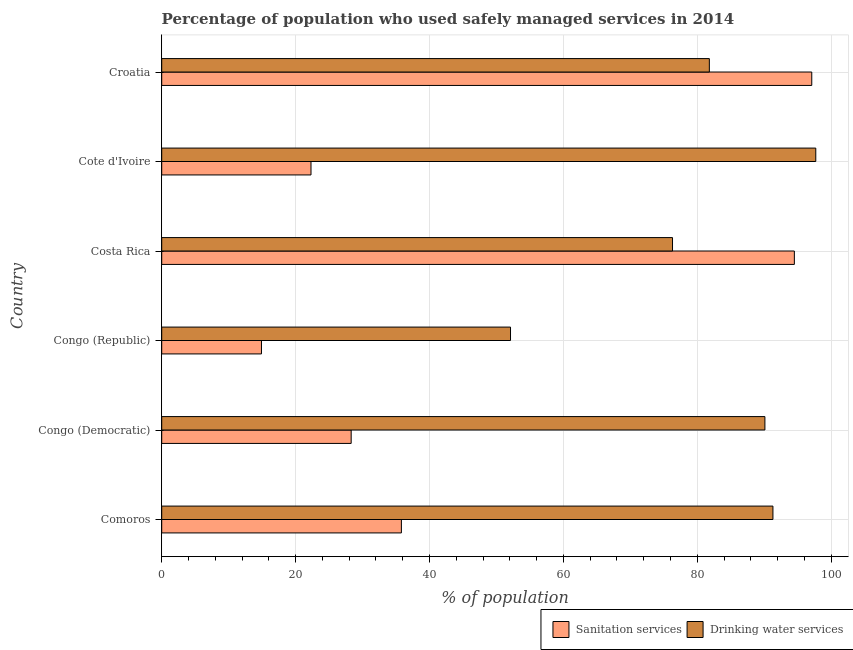How many different coloured bars are there?
Make the answer very short. 2. How many groups of bars are there?
Make the answer very short. 6. How many bars are there on the 3rd tick from the bottom?
Make the answer very short. 2. What is the label of the 5th group of bars from the top?
Ensure brevity in your answer.  Congo (Democratic). What is the percentage of population who used drinking water services in Comoros?
Provide a short and direct response. 91.3. Across all countries, what is the maximum percentage of population who used drinking water services?
Ensure brevity in your answer.  97.7. Across all countries, what is the minimum percentage of population who used sanitation services?
Make the answer very short. 14.9. In which country was the percentage of population who used sanitation services maximum?
Offer a terse response. Croatia. In which country was the percentage of population who used sanitation services minimum?
Provide a short and direct response. Congo (Republic). What is the total percentage of population who used sanitation services in the graph?
Keep it short and to the point. 292.9. What is the difference between the percentage of population who used sanitation services in Congo (Democratic) and the percentage of population who used drinking water services in Comoros?
Make the answer very short. -63. What is the average percentage of population who used sanitation services per country?
Give a very brief answer. 48.82. What is the difference between the percentage of population who used drinking water services and percentage of population who used sanitation services in Comoros?
Your answer should be very brief. 55.5. In how many countries, is the percentage of population who used sanitation services greater than 92 %?
Ensure brevity in your answer.  2. What is the ratio of the percentage of population who used drinking water services in Costa Rica to that in Cote d'Ivoire?
Give a very brief answer. 0.78. What is the difference between the highest and the lowest percentage of population who used sanitation services?
Keep it short and to the point. 82.2. In how many countries, is the percentage of population who used sanitation services greater than the average percentage of population who used sanitation services taken over all countries?
Offer a terse response. 2. What does the 1st bar from the top in Cote d'Ivoire represents?
Your response must be concise. Drinking water services. What does the 1st bar from the bottom in Costa Rica represents?
Provide a short and direct response. Sanitation services. How many bars are there?
Offer a very short reply. 12. What is the difference between two consecutive major ticks on the X-axis?
Your response must be concise. 20. Does the graph contain any zero values?
Offer a terse response. No. Where does the legend appear in the graph?
Make the answer very short. Bottom right. How are the legend labels stacked?
Ensure brevity in your answer.  Horizontal. What is the title of the graph?
Give a very brief answer. Percentage of population who used safely managed services in 2014. Does "Technicians" appear as one of the legend labels in the graph?
Provide a succinct answer. No. What is the label or title of the X-axis?
Your response must be concise. % of population. What is the % of population in Sanitation services in Comoros?
Your answer should be very brief. 35.8. What is the % of population of Drinking water services in Comoros?
Your answer should be very brief. 91.3. What is the % of population in Sanitation services in Congo (Democratic)?
Your answer should be compact. 28.3. What is the % of population of Drinking water services in Congo (Democratic)?
Provide a short and direct response. 90.1. What is the % of population of Drinking water services in Congo (Republic)?
Offer a very short reply. 52.1. What is the % of population in Sanitation services in Costa Rica?
Your answer should be very brief. 94.5. What is the % of population of Drinking water services in Costa Rica?
Give a very brief answer. 76.3. What is the % of population in Sanitation services in Cote d'Ivoire?
Ensure brevity in your answer.  22.3. What is the % of population of Drinking water services in Cote d'Ivoire?
Provide a succinct answer. 97.7. What is the % of population of Sanitation services in Croatia?
Provide a succinct answer. 97.1. What is the % of population of Drinking water services in Croatia?
Your answer should be very brief. 81.8. Across all countries, what is the maximum % of population of Sanitation services?
Ensure brevity in your answer.  97.1. Across all countries, what is the maximum % of population in Drinking water services?
Your answer should be compact. 97.7. Across all countries, what is the minimum % of population in Drinking water services?
Make the answer very short. 52.1. What is the total % of population in Sanitation services in the graph?
Your answer should be compact. 292.9. What is the total % of population of Drinking water services in the graph?
Offer a terse response. 489.3. What is the difference between the % of population of Sanitation services in Comoros and that in Congo (Democratic)?
Provide a short and direct response. 7.5. What is the difference between the % of population of Sanitation services in Comoros and that in Congo (Republic)?
Provide a succinct answer. 20.9. What is the difference between the % of population of Drinking water services in Comoros and that in Congo (Republic)?
Ensure brevity in your answer.  39.2. What is the difference between the % of population of Sanitation services in Comoros and that in Costa Rica?
Give a very brief answer. -58.7. What is the difference between the % of population in Drinking water services in Comoros and that in Costa Rica?
Provide a short and direct response. 15. What is the difference between the % of population of Drinking water services in Comoros and that in Cote d'Ivoire?
Offer a terse response. -6.4. What is the difference between the % of population of Sanitation services in Comoros and that in Croatia?
Provide a succinct answer. -61.3. What is the difference between the % of population of Drinking water services in Congo (Democratic) and that in Congo (Republic)?
Ensure brevity in your answer.  38. What is the difference between the % of population in Sanitation services in Congo (Democratic) and that in Costa Rica?
Your answer should be very brief. -66.2. What is the difference between the % of population in Sanitation services in Congo (Democratic) and that in Cote d'Ivoire?
Provide a succinct answer. 6. What is the difference between the % of population in Sanitation services in Congo (Democratic) and that in Croatia?
Provide a short and direct response. -68.8. What is the difference between the % of population in Drinking water services in Congo (Democratic) and that in Croatia?
Provide a short and direct response. 8.3. What is the difference between the % of population in Sanitation services in Congo (Republic) and that in Costa Rica?
Offer a terse response. -79.6. What is the difference between the % of population in Drinking water services in Congo (Republic) and that in Costa Rica?
Offer a terse response. -24.2. What is the difference between the % of population in Drinking water services in Congo (Republic) and that in Cote d'Ivoire?
Offer a terse response. -45.6. What is the difference between the % of population in Sanitation services in Congo (Republic) and that in Croatia?
Keep it short and to the point. -82.2. What is the difference between the % of population of Drinking water services in Congo (Republic) and that in Croatia?
Keep it short and to the point. -29.7. What is the difference between the % of population of Sanitation services in Costa Rica and that in Cote d'Ivoire?
Make the answer very short. 72.2. What is the difference between the % of population in Drinking water services in Costa Rica and that in Cote d'Ivoire?
Your response must be concise. -21.4. What is the difference between the % of population of Sanitation services in Cote d'Ivoire and that in Croatia?
Give a very brief answer. -74.8. What is the difference between the % of population in Sanitation services in Comoros and the % of population in Drinking water services in Congo (Democratic)?
Make the answer very short. -54.3. What is the difference between the % of population of Sanitation services in Comoros and the % of population of Drinking water services in Congo (Republic)?
Offer a terse response. -16.3. What is the difference between the % of population in Sanitation services in Comoros and the % of population in Drinking water services in Costa Rica?
Your answer should be very brief. -40.5. What is the difference between the % of population of Sanitation services in Comoros and the % of population of Drinking water services in Cote d'Ivoire?
Offer a very short reply. -61.9. What is the difference between the % of population in Sanitation services in Comoros and the % of population in Drinking water services in Croatia?
Keep it short and to the point. -46. What is the difference between the % of population in Sanitation services in Congo (Democratic) and the % of population in Drinking water services in Congo (Republic)?
Give a very brief answer. -23.8. What is the difference between the % of population in Sanitation services in Congo (Democratic) and the % of population in Drinking water services in Costa Rica?
Provide a succinct answer. -48. What is the difference between the % of population of Sanitation services in Congo (Democratic) and the % of population of Drinking water services in Cote d'Ivoire?
Make the answer very short. -69.4. What is the difference between the % of population of Sanitation services in Congo (Democratic) and the % of population of Drinking water services in Croatia?
Provide a succinct answer. -53.5. What is the difference between the % of population in Sanitation services in Congo (Republic) and the % of population in Drinking water services in Costa Rica?
Give a very brief answer. -61.4. What is the difference between the % of population in Sanitation services in Congo (Republic) and the % of population in Drinking water services in Cote d'Ivoire?
Your answer should be compact. -82.8. What is the difference between the % of population of Sanitation services in Congo (Republic) and the % of population of Drinking water services in Croatia?
Keep it short and to the point. -66.9. What is the difference between the % of population of Sanitation services in Cote d'Ivoire and the % of population of Drinking water services in Croatia?
Provide a succinct answer. -59.5. What is the average % of population of Sanitation services per country?
Your response must be concise. 48.82. What is the average % of population in Drinking water services per country?
Your response must be concise. 81.55. What is the difference between the % of population in Sanitation services and % of population in Drinking water services in Comoros?
Keep it short and to the point. -55.5. What is the difference between the % of population of Sanitation services and % of population of Drinking water services in Congo (Democratic)?
Your answer should be very brief. -61.8. What is the difference between the % of population in Sanitation services and % of population in Drinking water services in Congo (Republic)?
Provide a short and direct response. -37.2. What is the difference between the % of population in Sanitation services and % of population in Drinking water services in Cote d'Ivoire?
Your answer should be compact. -75.4. What is the ratio of the % of population in Sanitation services in Comoros to that in Congo (Democratic)?
Provide a short and direct response. 1.26. What is the ratio of the % of population of Drinking water services in Comoros to that in Congo (Democratic)?
Provide a short and direct response. 1.01. What is the ratio of the % of population in Sanitation services in Comoros to that in Congo (Republic)?
Provide a succinct answer. 2.4. What is the ratio of the % of population in Drinking water services in Comoros to that in Congo (Republic)?
Provide a short and direct response. 1.75. What is the ratio of the % of population in Sanitation services in Comoros to that in Costa Rica?
Give a very brief answer. 0.38. What is the ratio of the % of population in Drinking water services in Comoros to that in Costa Rica?
Ensure brevity in your answer.  1.2. What is the ratio of the % of population in Sanitation services in Comoros to that in Cote d'Ivoire?
Offer a terse response. 1.61. What is the ratio of the % of population in Drinking water services in Comoros to that in Cote d'Ivoire?
Your response must be concise. 0.93. What is the ratio of the % of population in Sanitation services in Comoros to that in Croatia?
Offer a very short reply. 0.37. What is the ratio of the % of population of Drinking water services in Comoros to that in Croatia?
Make the answer very short. 1.12. What is the ratio of the % of population of Sanitation services in Congo (Democratic) to that in Congo (Republic)?
Your answer should be very brief. 1.9. What is the ratio of the % of population of Drinking water services in Congo (Democratic) to that in Congo (Republic)?
Provide a short and direct response. 1.73. What is the ratio of the % of population of Sanitation services in Congo (Democratic) to that in Costa Rica?
Offer a very short reply. 0.3. What is the ratio of the % of population of Drinking water services in Congo (Democratic) to that in Costa Rica?
Your answer should be compact. 1.18. What is the ratio of the % of population of Sanitation services in Congo (Democratic) to that in Cote d'Ivoire?
Give a very brief answer. 1.27. What is the ratio of the % of population of Drinking water services in Congo (Democratic) to that in Cote d'Ivoire?
Your response must be concise. 0.92. What is the ratio of the % of population of Sanitation services in Congo (Democratic) to that in Croatia?
Keep it short and to the point. 0.29. What is the ratio of the % of population of Drinking water services in Congo (Democratic) to that in Croatia?
Provide a succinct answer. 1.1. What is the ratio of the % of population of Sanitation services in Congo (Republic) to that in Costa Rica?
Give a very brief answer. 0.16. What is the ratio of the % of population of Drinking water services in Congo (Republic) to that in Costa Rica?
Give a very brief answer. 0.68. What is the ratio of the % of population in Sanitation services in Congo (Republic) to that in Cote d'Ivoire?
Provide a short and direct response. 0.67. What is the ratio of the % of population in Drinking water services in Congo (Republic) to that in Cote d'Ivoire?
Offer a very short reply. 0.53. What is the ratio of the % of population of Sanitation services in Congo (Republic) to that in Croatia?
Keep it short and to the point. 0.15. What is the ratio of the % of population of Drinking water services in Congo (Republic) to that in Croatia?
Your response must be concise. 0.64. What is the ratio of the % of population in Sanitation services in Costa Rica to that in Cote d'Ivoire?
Offer a terse response. 4.24. What is the ratio of the % of population in Drinking water services in Costa Rica to that in Cote d'Ivoire?
Your answer should be very brief. 0.78. What is the ratio of the % of population of Sanitation services in Costa Rica to that in Croatia?
Give a very brief answer. 0.97. What is the ratio of the % of population in Drinking water services in Costa Rica to that in Croatia?
Your answer should be compact. 0.93. What is the ratio of the % of population in Sanitation services in Cote d'Ivoire to that in Croatia?
Provide a succinct answer. 0.23. What is the ratio of the % of population of Drinking water services in Cote d'Ivoire to that in Croatia?
Your response must be concise. 1.19. What is the difference between the highest and the lowest % of population in Sanitation services?
Your answer should be compact. 82.2. What is the difference between the highest and the lowest % of population of Drinking water services?
Offer a very short reply. 45.6. 